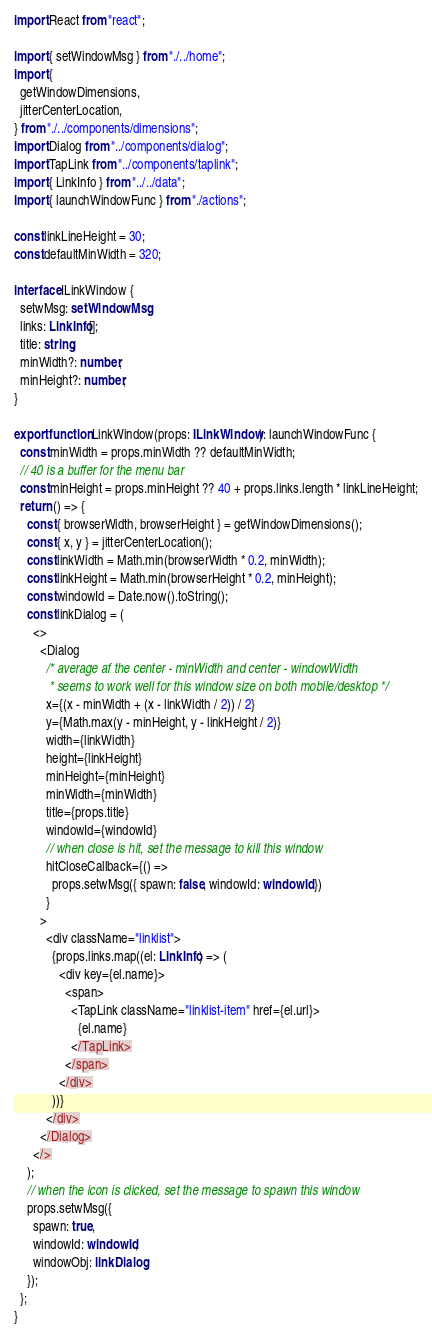<code> <loc_0><loc_0><loc_500><loc_500><_TypeScript_>import React from "react";

import { setWindowMsg } from "./../home";
import {
  getWindowDimensions,
  jitterCenterLocation,
} from "./../components/dimensions";
import Dialog from "../components/dialog";
import TapLink from "../components/taplink";
import { LinkInfo } from "../../data";
import { launchWindowFunc } from "./actions";

const linkLineHeight = 30;
const defaultMinWidth = 320;

interface ILinkWindow {
  setwMsg: setWindowMsg;
  links: LinkInfo[];
  title: string;
  minWidth?: number;
  minHeight?: number;
}

export function LinkWindow(props: ILinkWindow): launchWindowFunc {
  const minWidth = props.minWidth ?? defaultMinWidth;
  // 40 is a buffer for the menu bar
  const minHeight = props.minHeight ?? 40 + props.links.length * linkLineHeight;
  return () => {
    const { browserWidth, browserHeight } = getWindowDimensions();
    const { x, y } = jitterCenterLocation();
    const linkWidth = Math.min(browserWidth * 0.2, minWidth);
    const linkHeight = Math.min(browserHeight * 0.2, minHeight);
    const windowId = Date.now().toString();
    const linkDialog = (
      <>
        <Dialog
          /* average af the center - minWidth and center - windowWidth
           * seems to work well for this window size on both mobile/desktop */
          x={(x - minWidth + (x - linkWidth / 2)) / 2}
          y={Math.max(y - minHeight, y - linkHeight / 2)}
          width={linkWidth}
          height={linkHeight}
          minHeight={minHeight}
          minWidth={minWidth}
          title={props.title}
          windowId={windowId}
          // when close is hit, set the message to kill this window
          hitCloseCallback={() =>
            props.setwMsg({ spawn: false, windowId: windowId })
          }
        >
          <div className="linklist">
            {props.links.map((el: LinkInfo) => (
              <div key={el.name}>
                <span>
                  <TapLink className="linklist-item" href={el.url}>
                    {el.name}
                  </TapLink>
                </span>
              </div>
            ))}
          </div>
        </Dialog>
      </>
    );
    // when the icon is clicked, set the message to spawn this window
    props.setwMsg({
      spawn: true,
      windowId: windowId,
      windowObj: linkDialog,
    });
  };
}
</code> 